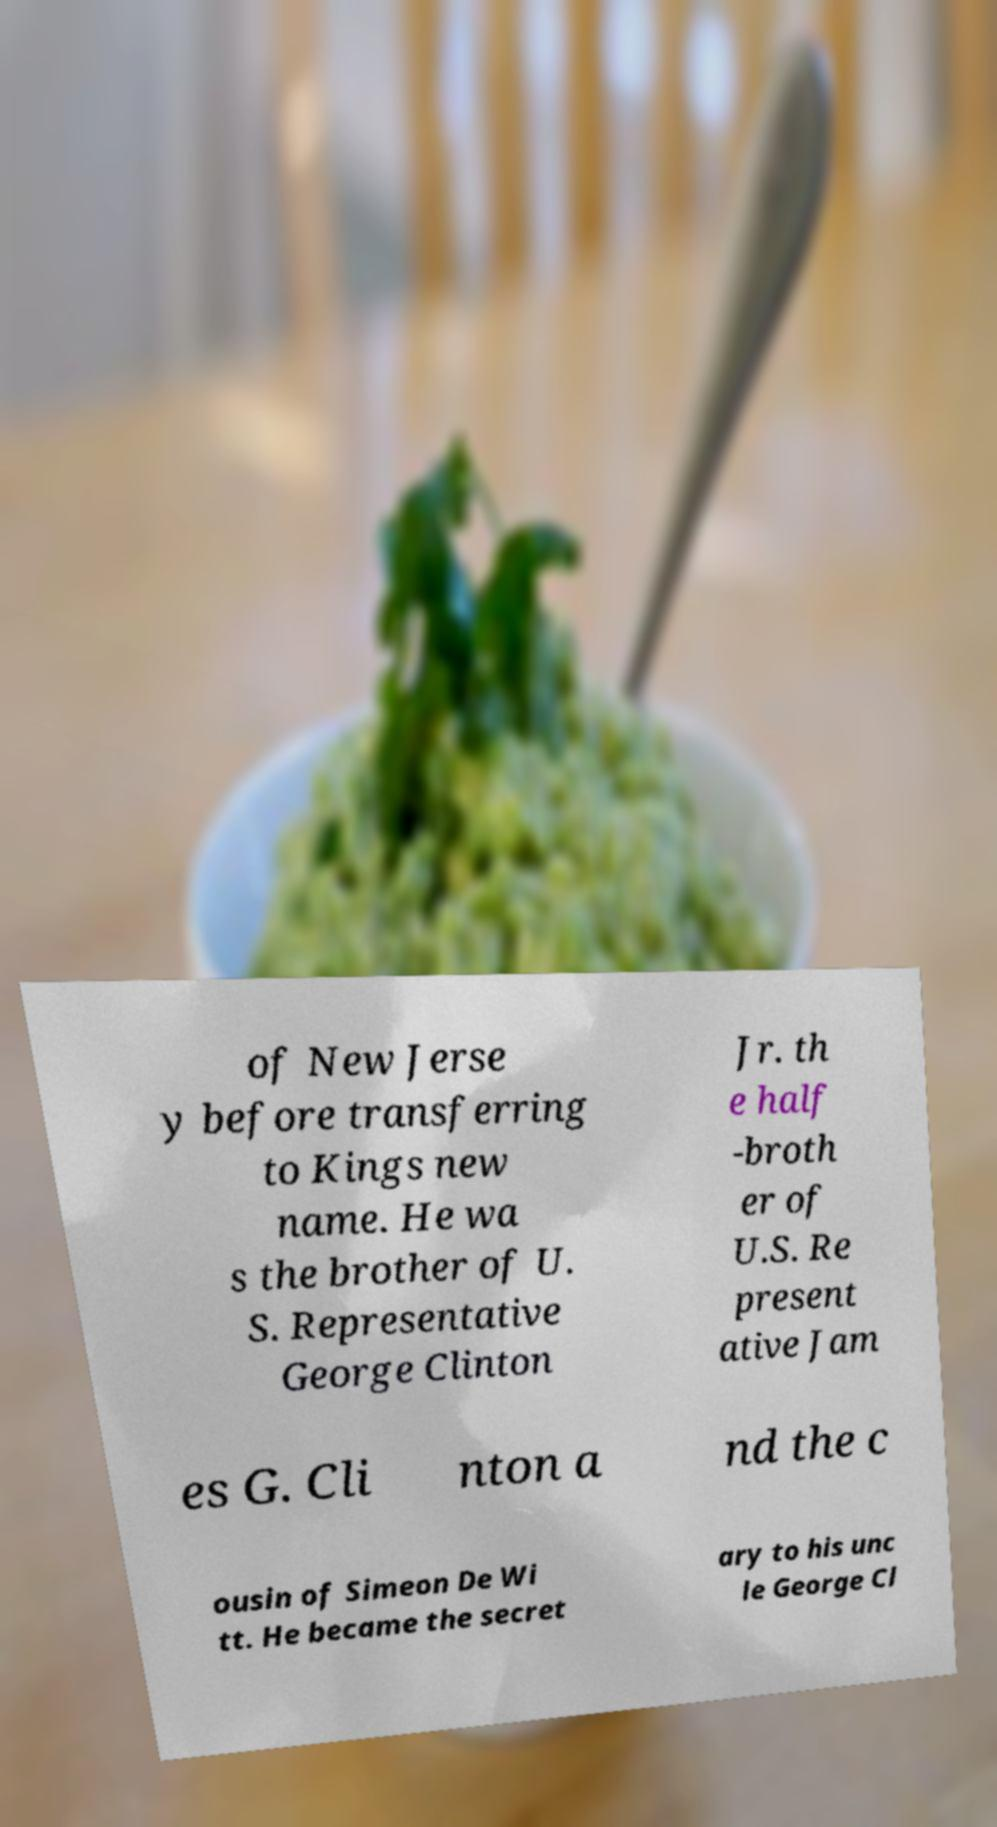Please identify and transcribe the text found in this image. of New Jerse y before transferring to Kings new name. He wa s the brother of U. S. Representative George Clinton Jr. th e half -broth er of U.S. Re present ative Jam es G. Cli nton a nd the c ousin of Simeon De Wi tt. He became the secret ary to his unc le George Cl 